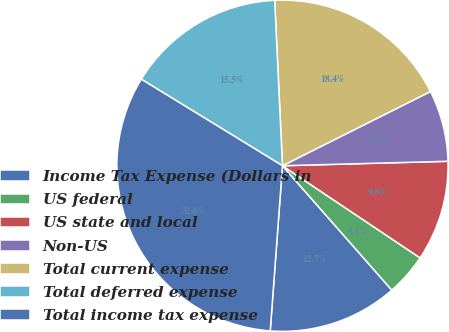Convert chart. <chart><loc_0><loc_0><loc_500><loc_500><pie_chart><fcel>Income Tax Expense (Dollars in<fcel>US federal<fcel>US state and local<fcel>Non-US<fcel>Total current expense<fcel>Total deferred expense<fcel>Total income tax expense<nl><fcel>12.66%<fcel>4.13%<fcel>9.82%<fcel>6.97%<fcel>18.35%<fcel>15.5%<fcel>32.57%<nl></chart> 